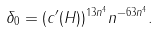Convert formula to latex. <formula><loc_0><loc_0><loc_500><loc_500>\delta _ { 0 } = ( c ^ { \prime } ( H ) ) ^ { 1 3 n ^ { 4 } } n ^ { - 6 3 n ^ { 4 } } .</formula> 